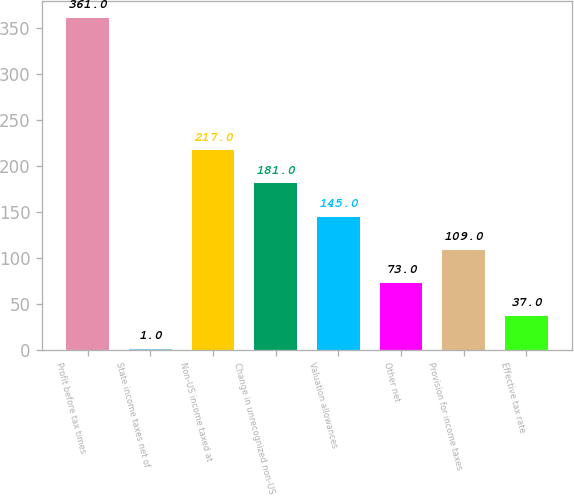<chart> <loc_0><loc_0><loc_500><loc_500><bar_chart><fcel>Profit before tax times<fcel>State income taxes net of<fcel>Non-US income taxed at<fcel>Change in unrecognized non-US<fcel>Valuation allowances<fcel>Other net<fcel>Provision for income taxes<fcel>Effective tax rate<nl><fcel>361<fcel>1<fcel>217<fcel>181<fcel>145<fcel>73<fcel>109<fcel>37<nl></chart> 